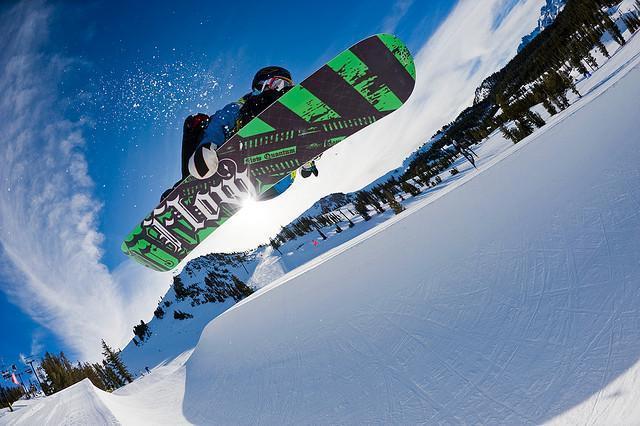How many cars are to the left of the carriage?
Give a very brief answer. 0. 